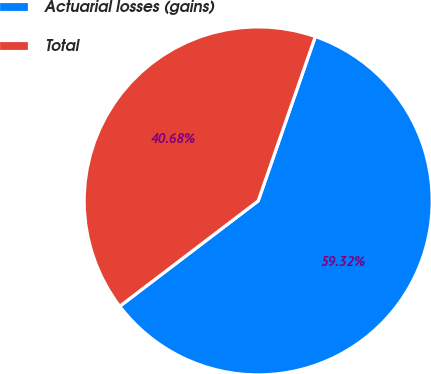<chart> <loc_0><loc_0><loc_500><loc_500><pie_chart><fcel>Actuarial losses (gains)<fcel>Total<nl><fcel>59.32%<fcel>40.68%<nl></chart> 